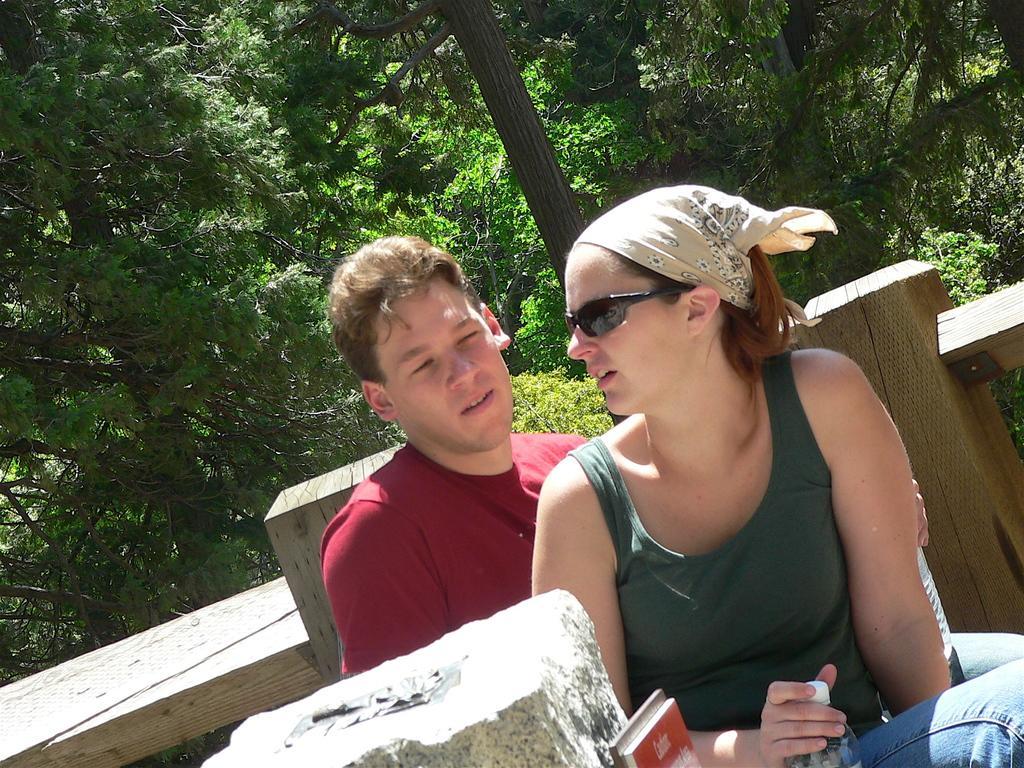Please provide a concise description of this image. In this picture there is a woman sitting and holding the bottle and there is a man sitting and holding the bottle. At the back there is a wooden railing and there are trees. 